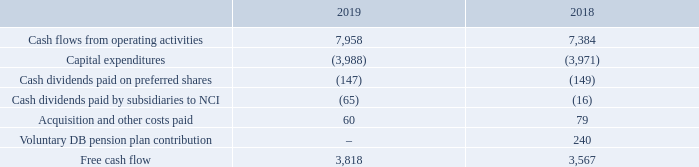FREE CASH FLOW AND DIVIDEND PAYOUT RATIO
The terms free cash flow and dividend payout ratio do not have any standardized meaning under IFRS. Therefore, they are unlikely to be comparable to similar measures presented by other issuers.
We define free cash flow as cash flows from operating activities, excluding acquisition and other costs paid (which include significant litigation costs) and voluntary pension funding, less capital expenditures, preferred share dividends and dividends paid by subsidiaries to NCI. We exclude acquisition and other costs paid and voluntary pension funding because they affect the comparability of our financial results and could potentially distort the analysis of trends in business performance. Excluding these items does not imply they are non-recurring.
We consider free cash flow to be an important indicator of the financial strength and performance of our businesses because it shows how much cash is available to pay dividends on common shares, repay debt and reinvest in our company. We believe that certain investors and analysts use free cash flow to value a business and its underlying assets and to evaluate the financial strength and performance of our businesses. The most comparable IFRS financial measure is cash flows from operating activities.
We define dividend payout ratio as dividends paid on common shares divided by free cash flow. We consider dividend payout ratio to be an important indicator of the financial strength and performance of our businesses because it shows the sustainability of the company’s dividend payments.
The following table is a reconciliation of cash flows from operating activities to free cash flow on a consolidated basis.
How is free cash flow defined? Cash flows from operating activities, excluding acquisition and other costs paid (which include significant litigation costs) and voluntary pension funding, less capital expenditures, preferred share dividends and dividends paid by subsidiaries to nci. Why is free cash flow considered an important indicator of the financial strength and performance of BCE's businesses? Because it shows how much cash is available to pay dividends on common shares, repay debt and reinvest in our company. What is  Cash flows from operating activities for 2018? 7,384. What is the change in cash flows from operating activities? 7,958-7,384
Answer: 574. What is the percentage change in free cash flow in 2019?
Answer scale should be: percent. (3,818-3,567)/3,567
Answer: 7.04. What is the total amount of acquisition and other costs paid in 2018 and 2019? 60+79
Answer: 139. 